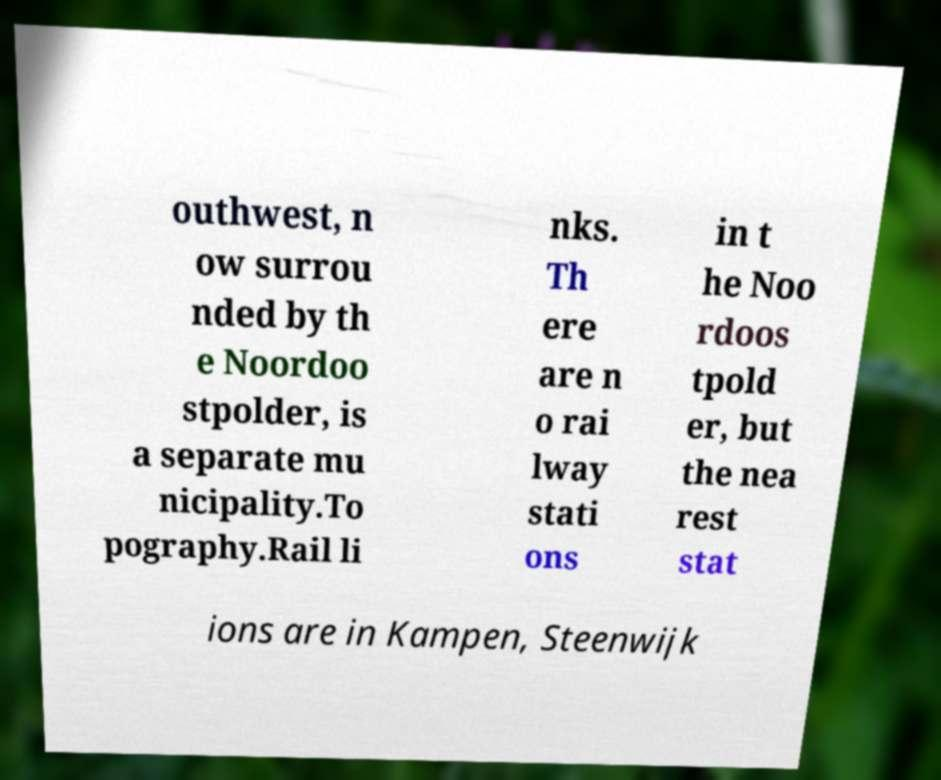Can you read and provide the text displayed in the image?This photo seems to have some interesting text. Can you extract and type it out for me? outhwest, n ow surrou nded by th e Noordoo stpolder, is a separate mu nicipality.To pography.Rail li nks. Th ere are n o rai lway stati ons in t he Noo rdoos tpold er, but the nea rest stat ions are in Kampen, Steenwijk 